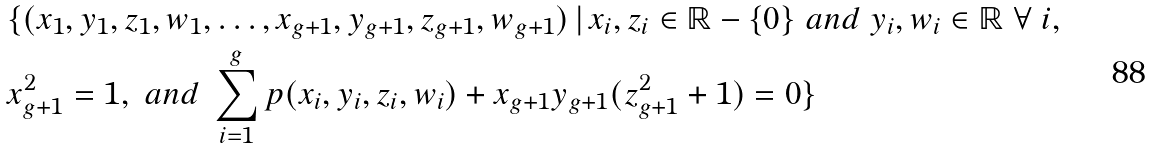<formula> <loc_0><loc_0><loc_500><loc_500>& \{ ( x _ { 1 } , y _ { 1 } , z _ { 1 } , w _ { 1 } , \hdots , x _ { g + 1 } , y _ { g + 1 } , z _ { g + 1 } , w _ { g + 1 } ) \, | \, x _ { i } , z _ { i } \in \mathbb { R } - \{ 0 \} \ a n d \ y _ { i } , w _ { i } \in \mathbb { R } \ \forall \ i , \\ & x _ { g + 1 } ^ { 2 } = 1 , \ a n d \ \sum _ { i = 1 } ^ { g } p ( x _ { i } , y _ { i } , z _ { i } , w _ { i } ) + x _ { g + 1 } y _ { g + 1 } ( z _ { g + 1 } ^ { 2 } + 1 ) = 0 \}</formula> 